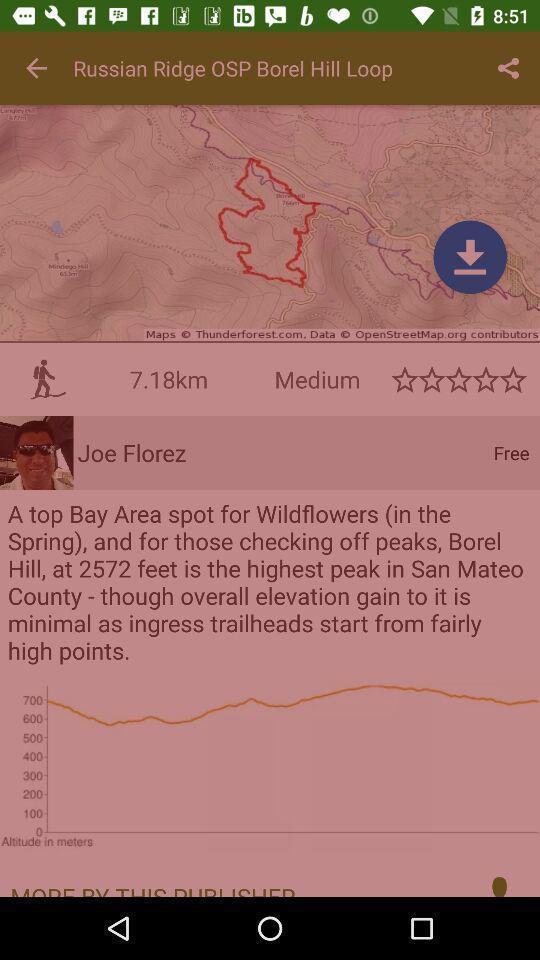What can you discern from this picture? Screen showing page. 